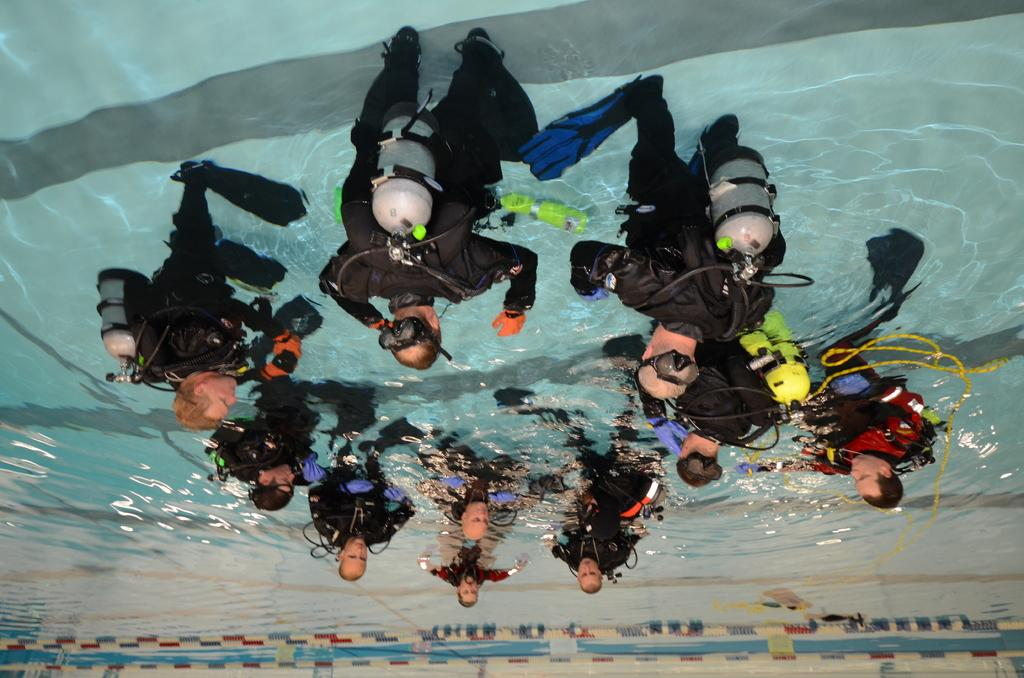How is the image presented in terms of orientation? The image is inverted. What can be seen in the inverted image? There is water visible in the image, and there are people in the water. What are the people wearing in the image? The people are wearing black dresses. What additional feature can be observed on the people in the image? The people have cylinders attached to their backs. Are there any jellyfish visible in the water in the image? There is no mention of jellyfish in the provided facts, so we cannot determine their presence in the image. What type of nail is being used by the people in the image? There is no mention of nails or any nail-related activities in the provided facts, so we cannot determine their presence or use in the image. 